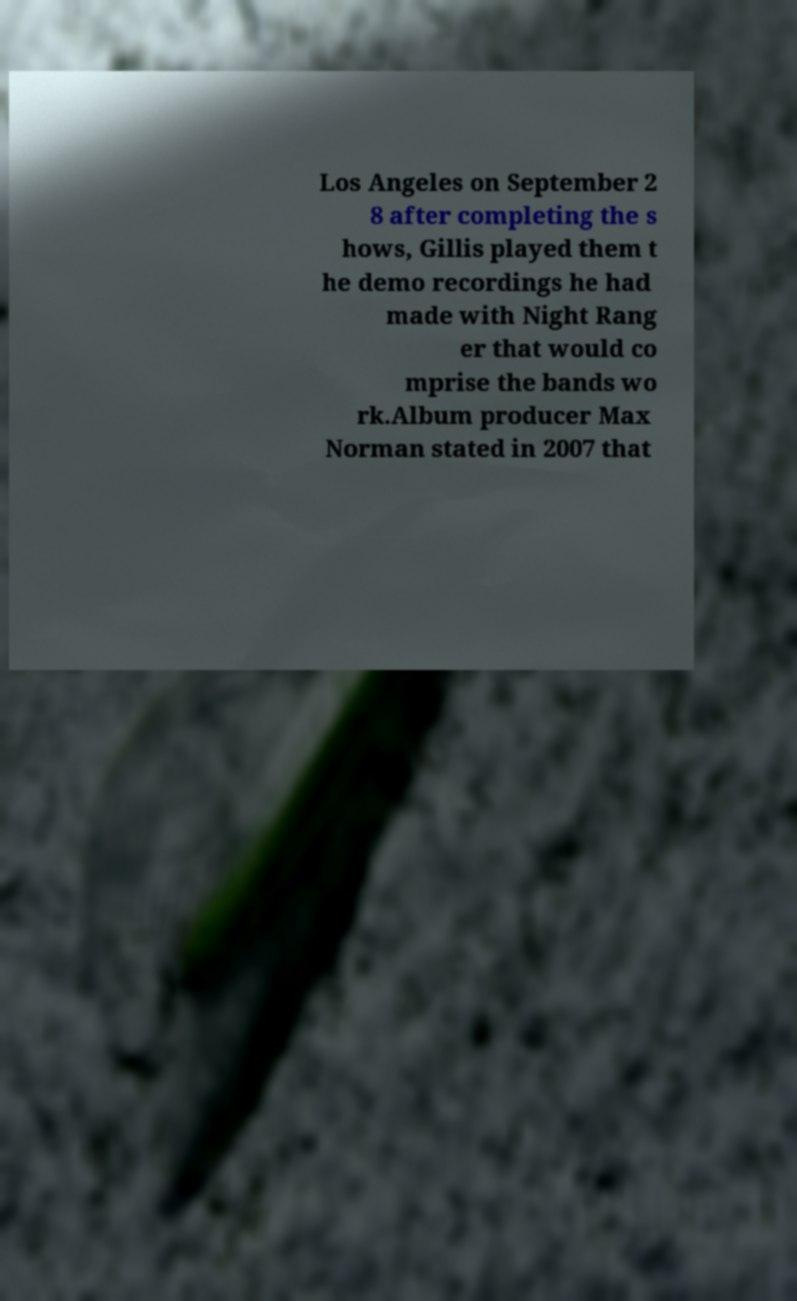There's text embedded in this image that I need extracted. Can you transcribe it verbatim? Los Angeles on September 2 8 after completing the s hows, Gillis played them t he demo recordings he had made with Night Rang er that would co mprise the bands wo rk.Album producer Max Norman stated in 2007 that 